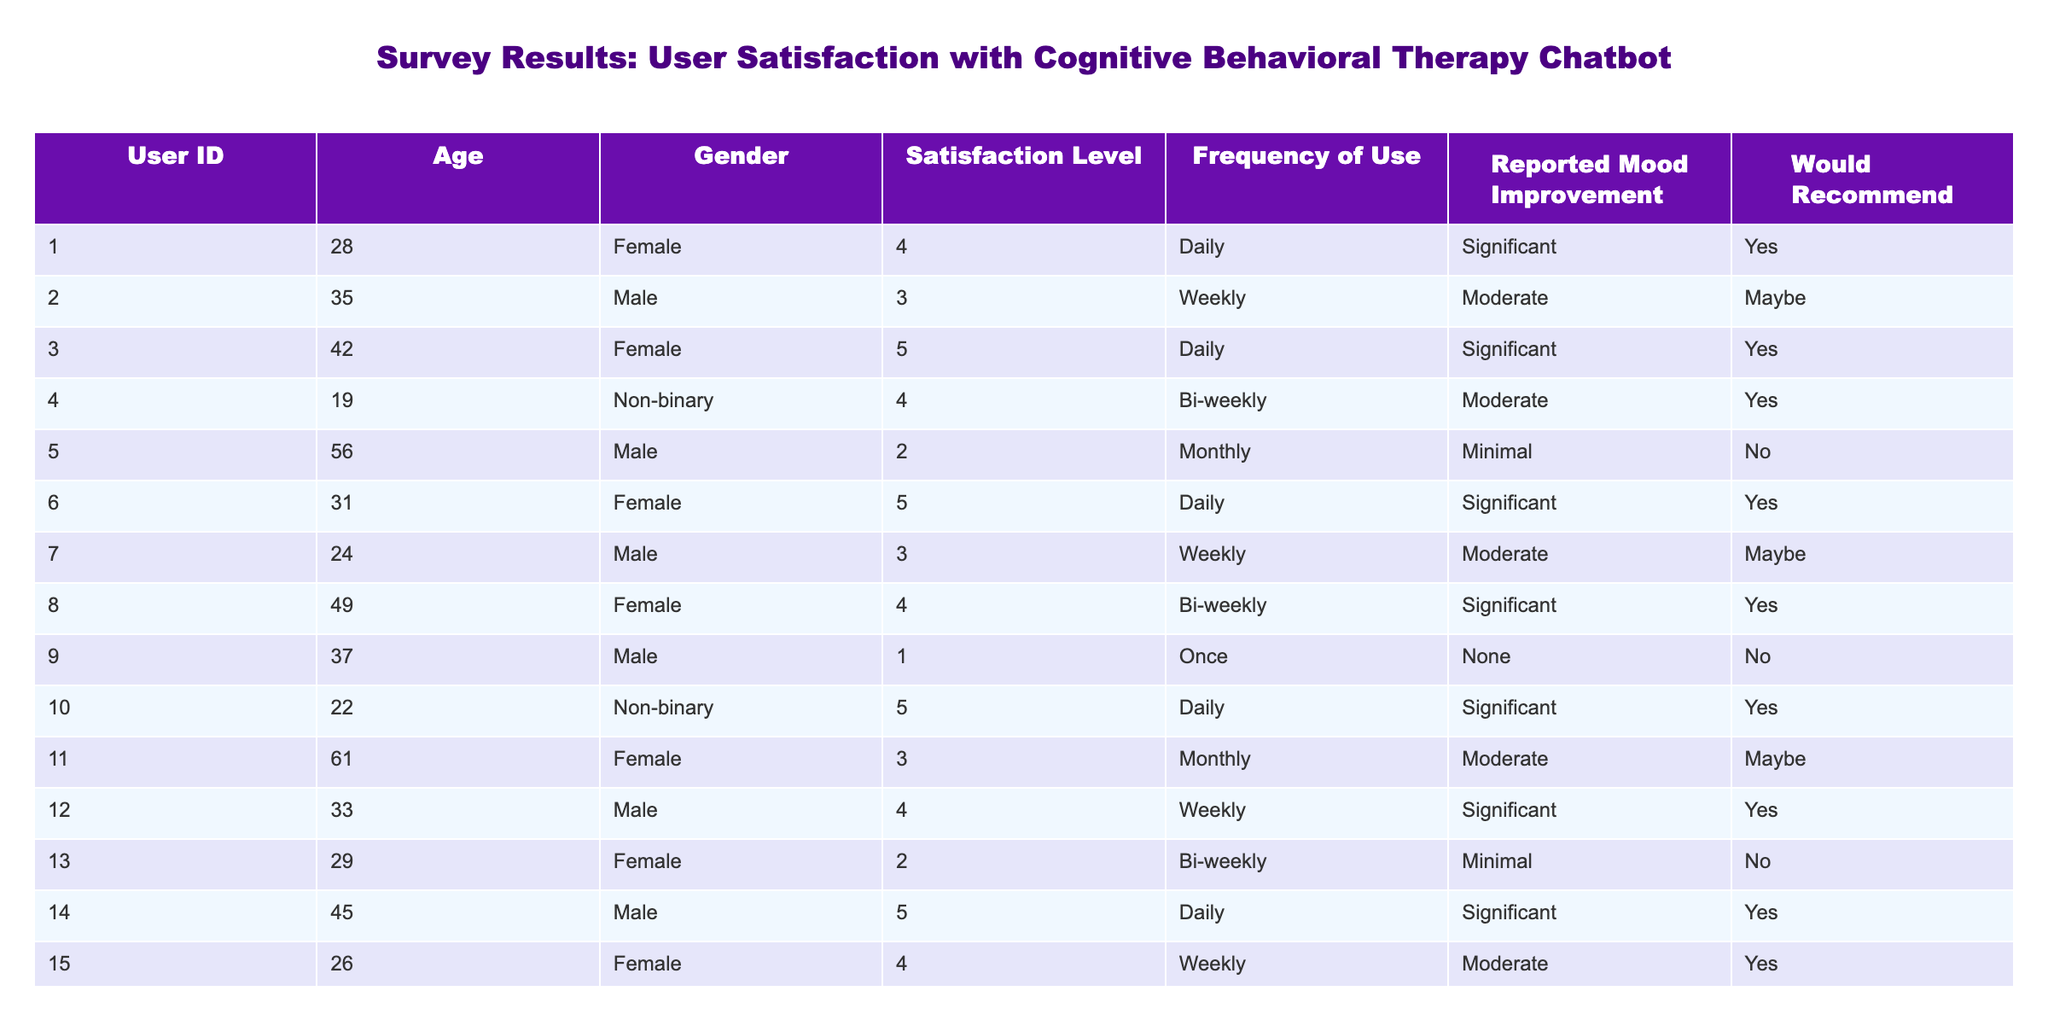What is the satisfaction level of User ID 7? Referring to the table, User ID 7 has a satisfaction level of 3.
Answer: 3 How many users reported a significant mood improvement? By reviewing the 'Reported Mood Improvement' column, we can find that Users IDs 1, 3, 6, 8, 10, 12, and 14 all reported a significant mood improvement, which counts to a total of 7 users.
Answer: 7 What is the average satisfaction level of all users? To calculate the average satisfaction level, we first sum all the satisfaction levels: 4 + 3 + 5 + 4 + 2 + 5 + 3 + 4 + 1 + 5 + 3 + 4 + 2 + 5 + 4 = 57. We divide the total by 15 (the number of users), yielding an average of 57 / 15 = 3.8.
Answer: 3.8 Is there a user who would recommend the chatbot but reported minimal mood improvement? Yes, User ID 13 would recommend the chatbot, but reported minimal mood improvement according to the 'Would Recommend' and 'Reported Mood Improvement' columns.
Answer: Yes What is the satisfaction level of users who use the chatbot daily? Users who use the chatbot daily are IDs 1, 3, 6, 10, and 14. Their satisfaction levels are 4, 5, 5, 5, and 5 respectively. The average satisfaction level of these users is (4 + 5 + 5 + 5 + 5) / 5 = 4.8.
Answer: 4.8 How many male users would recommend the chatbot? Analyzing the 'Would Recommend' column for male users, we find that Users IDs 2, 7, 9, 11, and 12 are male, and out of these, IDs 2, 12 would recommend, giving a total of 2 male users who would recommend.
Answer: 2 What percentage of users aged 30 and above reported a satisfaction level of 4 or higher? Users aged 30 and above are IDs 2, 3, 5, 6, 8, 9, 11, 12, and 14 (totaling 9 users). Out of these, IDs 3, 6, 8, 12, and 14 have a satisfaction level of 4 or higher (5 users). Thus, the percentage is (5 / 9) * 100 = approximately 55.56%.
Answer: 55.56% What is the mood improvement status of the user with the highest satisfaction level? User ID 6 has the highest satisfaction level of 5 and reported a significant mood improvement according to the table.
Answer: Significant 